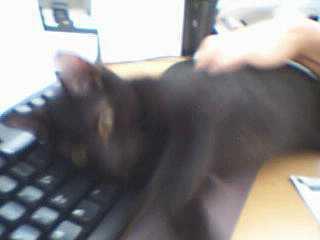How many cats are there?
Give a very brief answer. 1. 